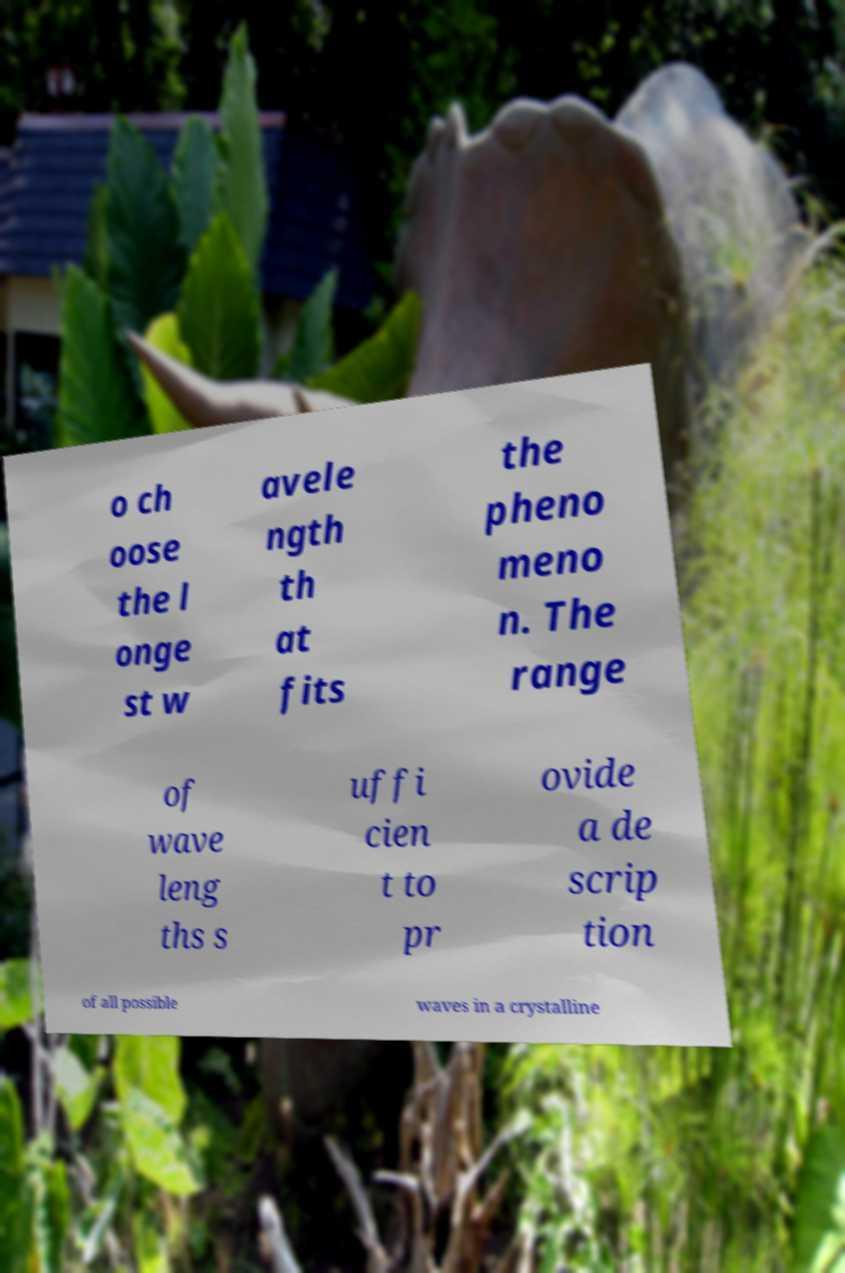Please read and relay the text visible in this image. What does it say? o ch oose the l onge st w avele ngth th at fits the pheno meno n. The range of wave leng ths s uffi cien t to pr ovide a de scrip tion of all possible waves in a crystalline 